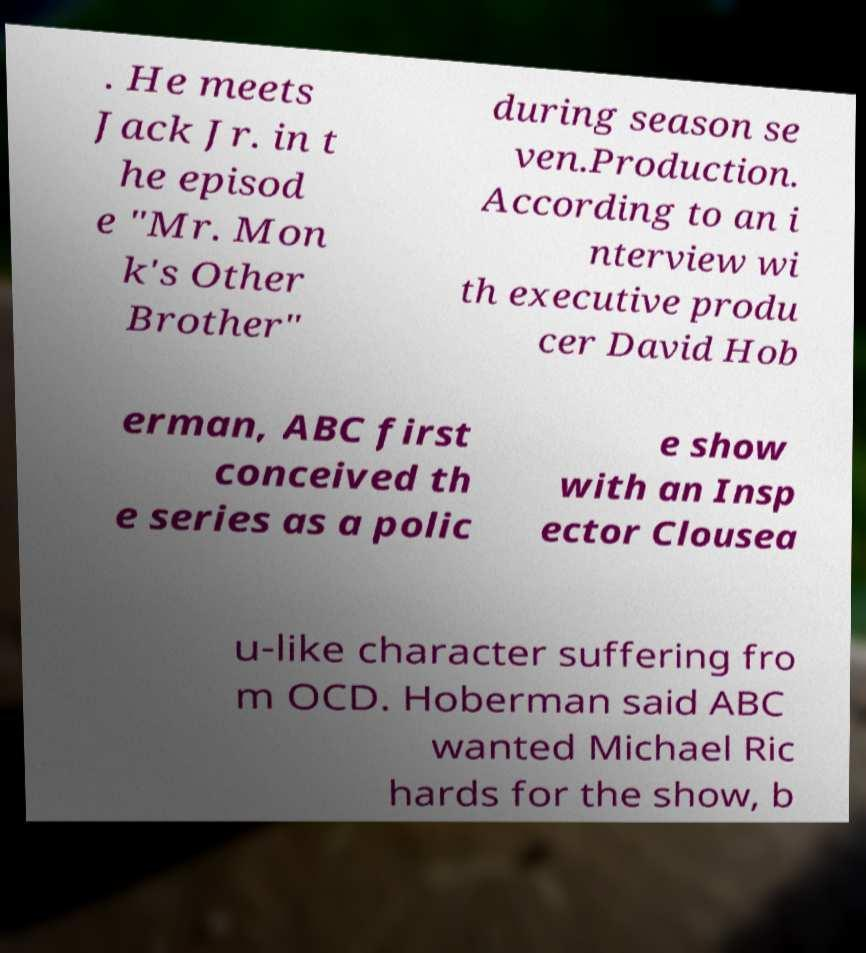Please read and relay the text visible in this image. What does it say? . He meets Jack Jr. in t he episod e "Mr. Mon k's Other Brother" during season se ven.Production. According to an i nterview wi th executive produ cer David Hob erman, ABC first conceived th e series as a polic e show with an Insp ector Clousea u-like character suffering fro m OCD. Hoberman said ABC wanted Michael Ric hards for the show, b 